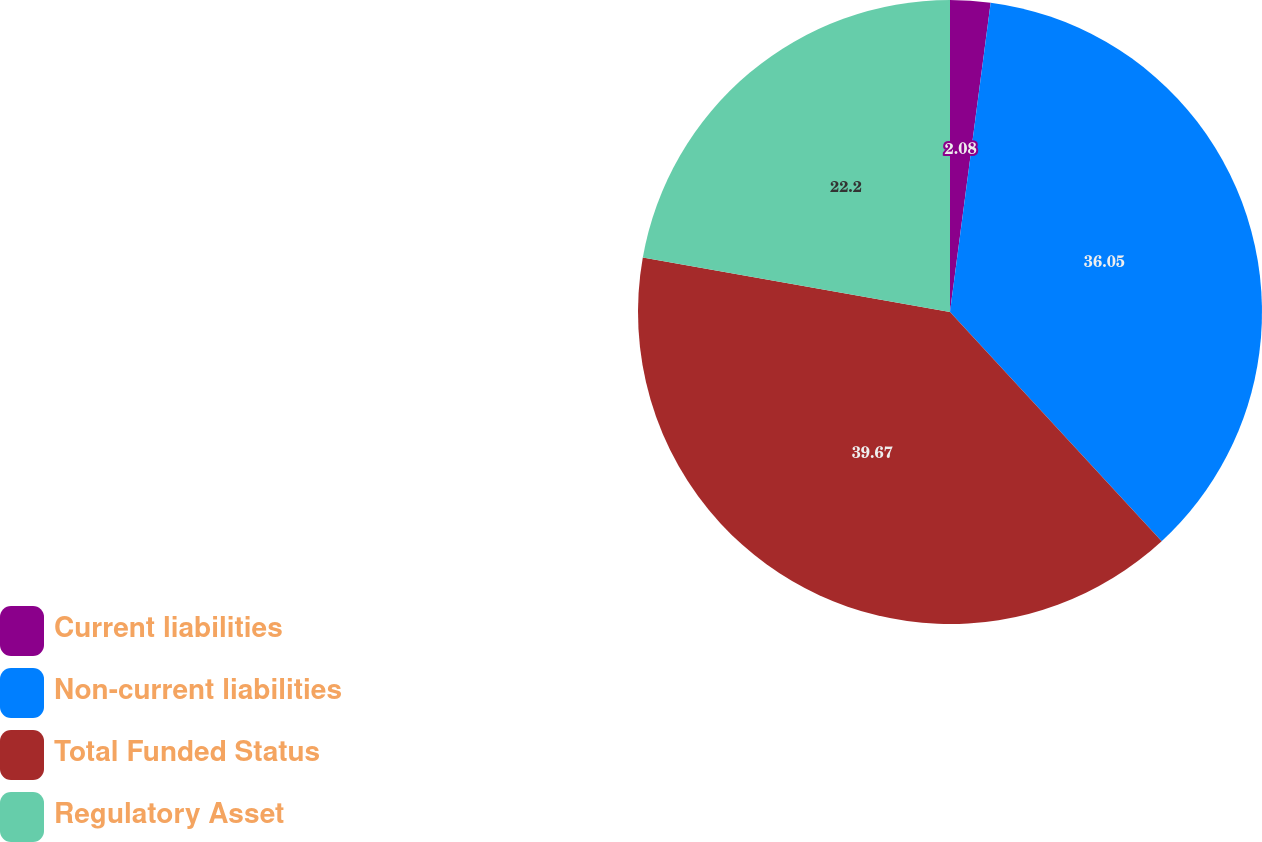<chart> <loc_0><loc_0><loc_500><loc_500><pie_chart><fcel>Current liabilities<fcel>Non-current liabilities<fcel>Total Funded Status<fcel>Regulatory Asset<nl><fcel>2.08%<fcel>36.05%<fcel>39.66%<fcel>22.2%<nl></chart> 